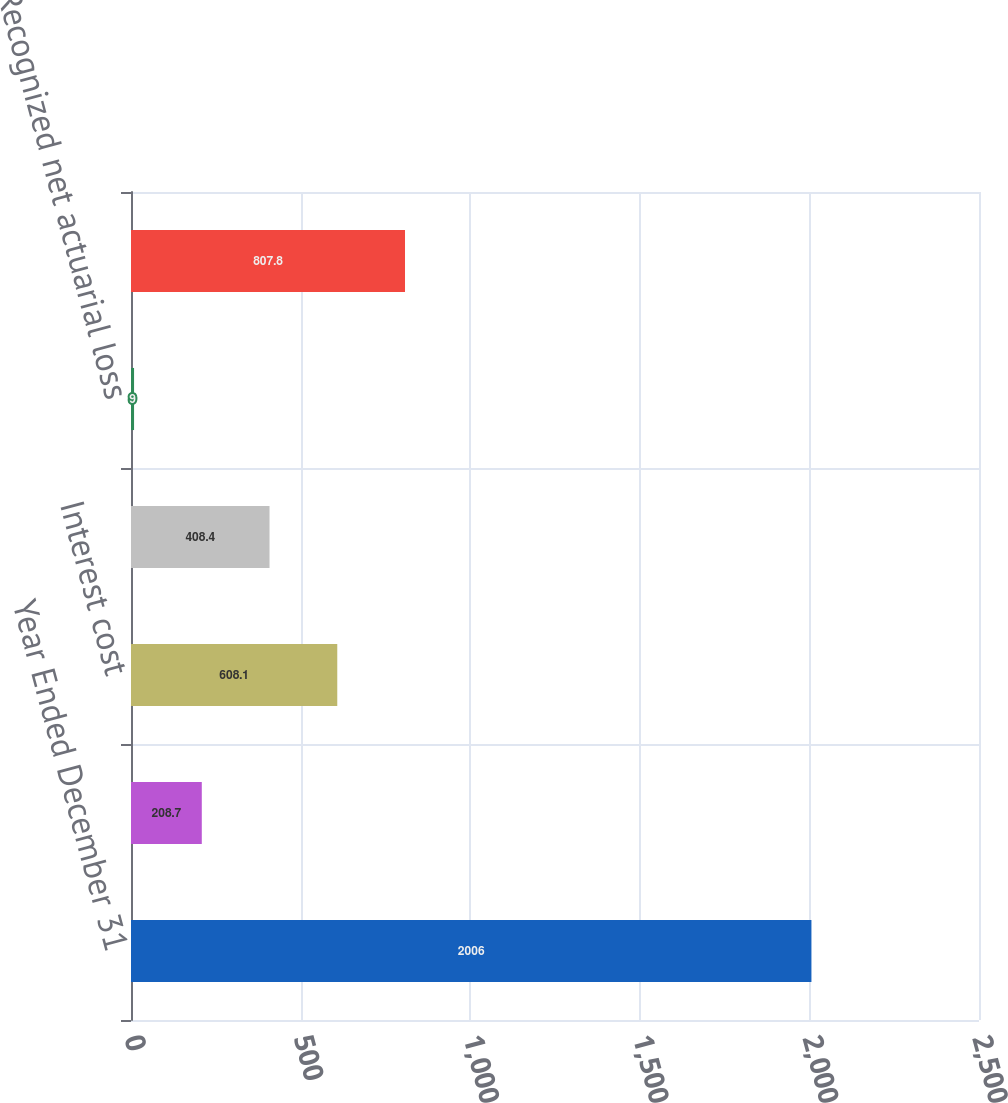Convert chart. <chart><loc_0><loc_0><loc_500><loc_500><bar_chart><fcel>Year Ended December 31<fcel>Service cost<fcel>Interest cost<fcel>Expected return on plan assets<fcel>Recognized net actuarial loss<fcel>Net periodic cost<nl><fcel>2006<fcel>208.7<fcel>608.1<fcel>408.4<fcel>9<fcel>807.8<nl></chart> 